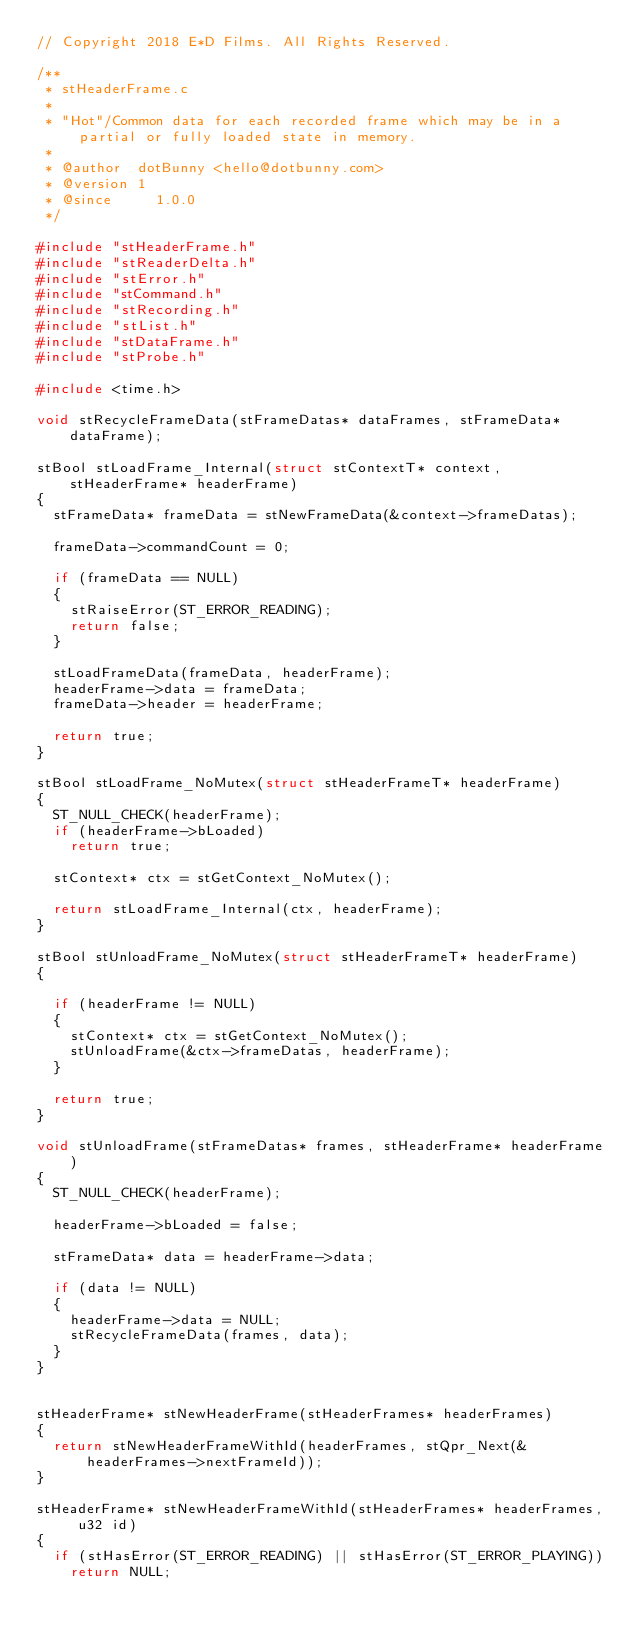<code> <loc_0><loc_0><loc_500><loc_500><_C_>// Copyright 2018 E*D Films. All Rights Reserved.

/**
 * stHeaderFrame.c
 *
 * "Hot"/Common data for each recorded frame which may be in a partial or fully loaded state in memory.
 * 
 * @author  dotBunny <hello@dotbunny.com>
 * @version 1
 * @since	  1.0.0
 */

#include "stHeaderFrame.h"
#include "stReaderDelta.h"
#include "stError.h"
#include "stCommand.h"
#include "stRecording.h"
#include "stList.h"
#include "stDataFrame.h"
#include "stProbe.h"

#include <time.h>

void stRecycleFrameData(stFrameDatas* dataFrames, stFrameData* dataFrame);

stBool stLoadFrame_Internal(struct stContextT* context, stHeaderFrame* headerFrame)
{
  stFrameData* frameData = stNewFrameData(&context->frameDatas);

  frameData->commandCount = 0;

  if (frameData == NULL)
  {
    stRaiseError(ST_ERROR_READING);
    return false;
  }

  stLoadFrameData(frameData, headerFrame);
  headerFrame->data = frameData;
  frameData->header = headerFrame;

  return true;
}

stBool stLoadFrame_NoMutex(struct stHeaderFrameT* headerFrame)
{
  ST_NULL_CHECK(headerFrame);
  if (headerFrame->bLoaded)
    return true;

  stContext* ctx = stGetContext_NoMutex();

  return stLoadFrame_Internal(ctx, headerFrame);
}

stBool stUnloadFrame_NoMutex(struct stHeaderFrameT* headerFrame)
{

  if (headerFrame != NULL)
  {
    stContext* ctx = stGetContext_NoMutex();
    stUnloadFrame(&ctx->frameDatas, headerFrame);
  }

  return true;
}

void stUnloadFrame(stFrameDatas* frames, stHeaderFrame* headerFrame)
{
  ST_NULL_CHECK(headerFrame);

  headerFrame->bLoaded = false;

  stFrameData* data = headerFrame->data;

  if (data != NULL)
  {
    headerFrame->data = NULL;
    stRecycleFrameData(frames, data);
  }
}


stHeaderFrame* stNewHeaderFrame(stHeaderFrames* headerFrames)
{
  return stNewHeaderFrameWithId(headerFrames, stQpr_Next(&headerFrames->nextFrameId));
}

stHeaderFrame* stNewHeaderFrameWithId(stHeaderFrames* headerFrames, u32 id)
{
  if (stHasError(ST_ERROR_READING) || stHasError(ST_ERROR_PLAYING))
    return NULL;
</code> 